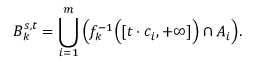Convert formula to latex. <formula><loc_0><loc_0><loc_500><loc_500>B _ { k } ^ { s , t } = \bigcup _ { i = 1 } ^ { m } { \left ( } f _ { k } ^ { - 1 } { \left ( } [ t \cdot c _ { i } , + \infty ] { \right ) } \cap A _ { i } { \right ) } .</formula> 